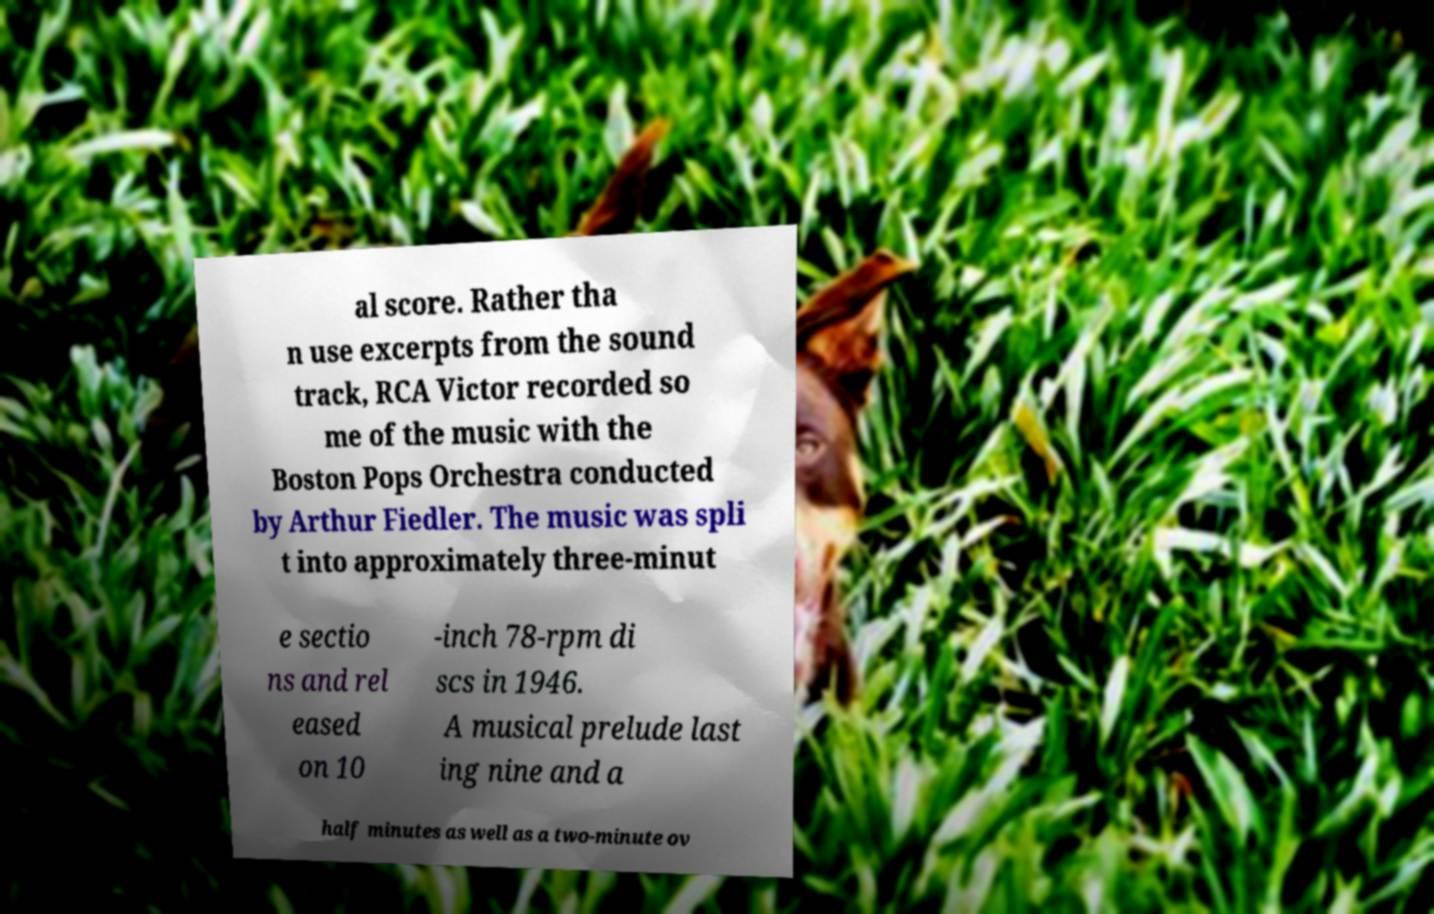There's text embedded in this image that I need extracted. Can you transcribe it verbatim? al score. Rather tha n use excerpts from the sound track, RCA Victor recorded so me of the music with the Boston Pops Orchestra conducted by Arthur Fiedler. The music was spli t into approximately three-minut e sectio ns and rel eased on 10 -inch 78-rpm di scs in 1946. A musical prelude last ing nine and a half minutes as well as a two-minute ov 